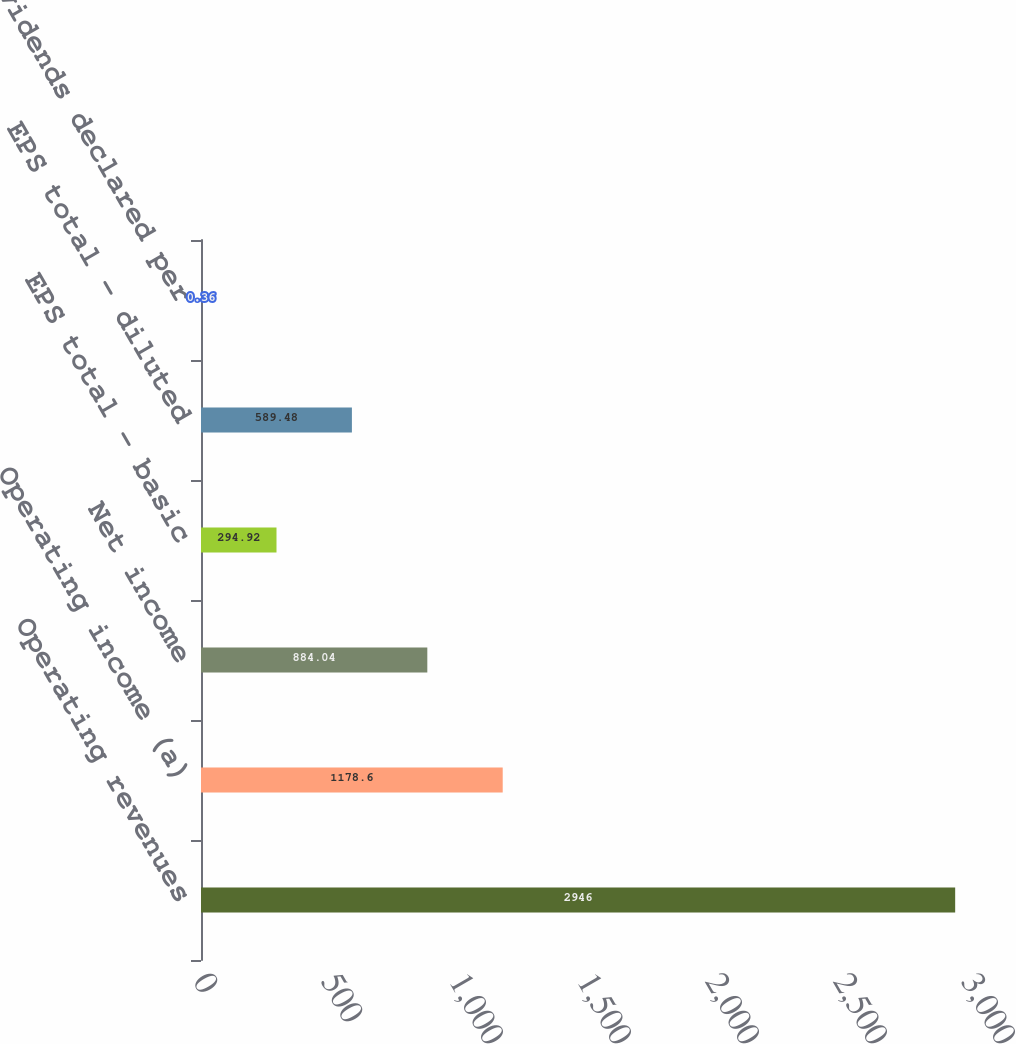Convert chart to OTSL. <chart><loc_0><loc_0><loc_500><loc_500><bar_chart><fcel>Operating revenues<fcel>Operating income (a)<fcel>Net income<fcel>EPS total - basic<fcel>EPS total - diluted<fcel>Cash dividends declared per<nl><fcel>2946<fcel>1178.6<fcel>884.04<fcel>294.92<fcel>589.48<fcel>0.36<nl></chart> 